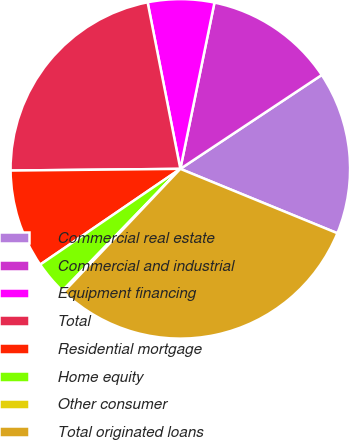Convert chart. <chart><loc_0><loc_0><loc_500><loc_500><pie_chart><fcel>Commercial real estate<fcel>Commercial and industrial<fcel>Equipment financing<fcel>Total<fcel>Residential mortgage<fcel>Home equity<fcel>Other consumer<fcel>Total originated loans<nl><fcel>15.52%<fcel>12.45%<fcel>6.31%<fcel>22.07%<fcel>9.38%<fcel>3.23%<fcel>0.16%<fcel>30.88%<nl></chart> 